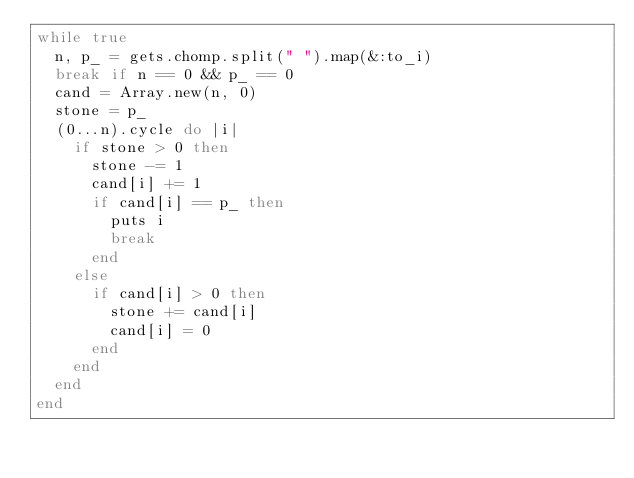<code> <loc_0><loc_0><loc_500><loc_500><_Ruby_>while true
  n, p_ = gets.chomp.split(" ").map(&:to_i)
  break if n == 0 && p_ == 0
  cand = Array.new(n, 0)
  stone = p_
  (0...n).cycle do |i|
    if stone > 0 then
      stone -= 1
      cand[i] += 1
      if cand[i] == p_ then
        puts i
        break
      end
    else
      if cand[i] > 0 then
        stone += cand[i]
        cand[i] = 0
      end
    end
  end
end</code> 